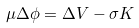<formula> <loc_0><loc_0><loc_500><loc_500>\mu \Delta \phi = \Delta V - \sigma K \</formula> 